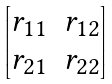<formula> <loc_0><loc_0><loc_500><loc_500>\begin{bmatrix} r _ { 1 1 } & r _ { 1 2 } \\ r _ { 2 1 } & r _ { 2 2 } \end{bmatrix}</formula> 